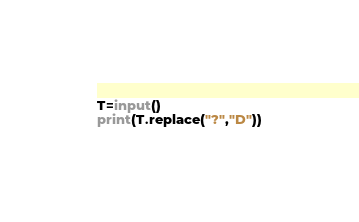<code> <loc_0><loc_0><loc_500><loc_500><_Python_>T=input()
print(T.replace("?","D"))
</code> 